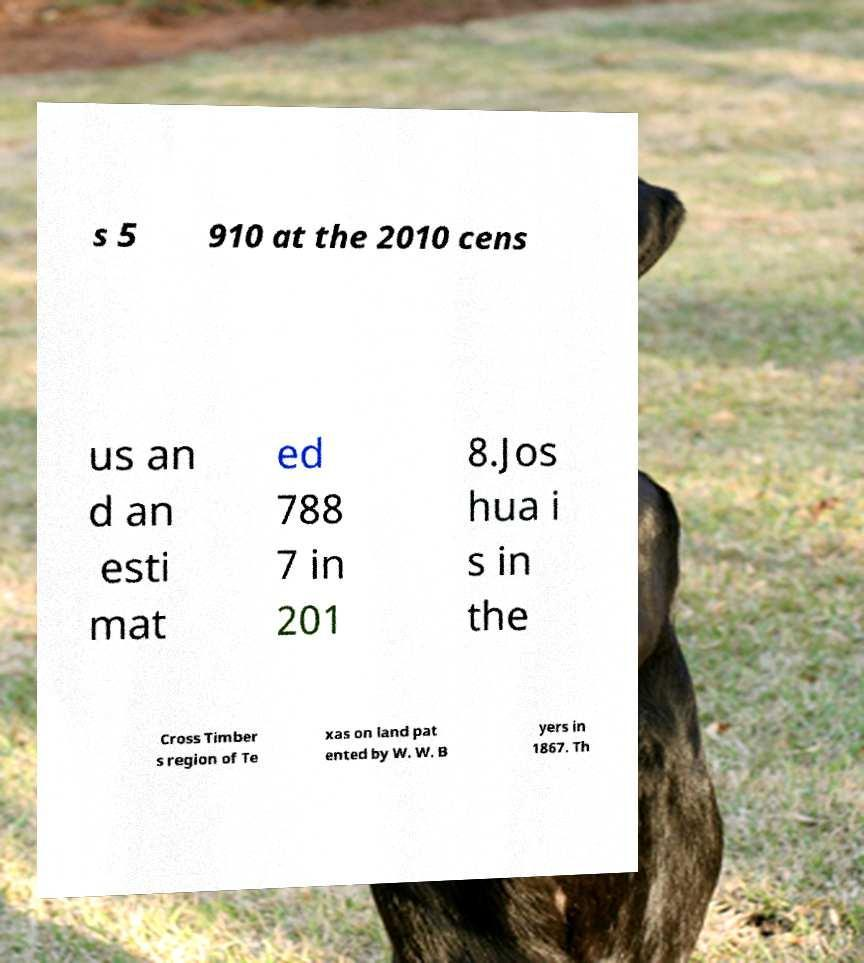I need the written content from this picture converted into text. Can you do that? s 5 910 at the 2010 cens us an d an esti mat ed 788 7 in 201 8.Jos hua i s in the Cross Timber s region of Te xas on land pat ented by W. W. B yers in 1867. Th 